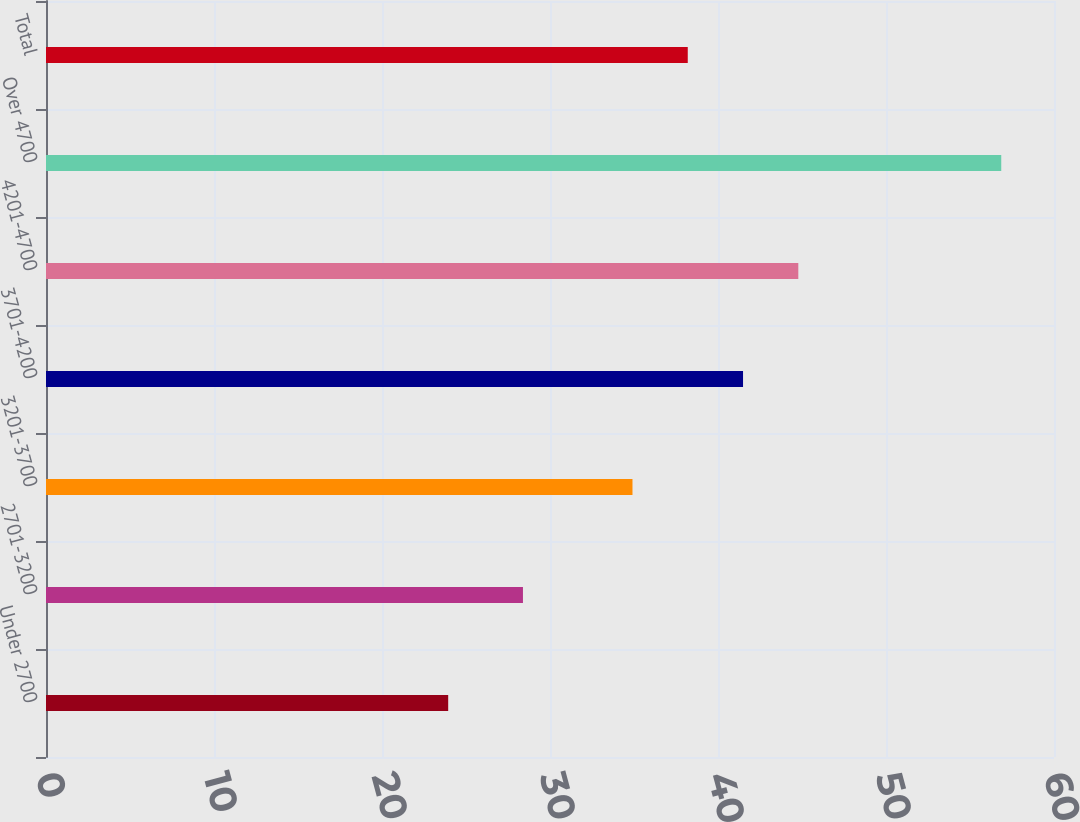Convert chart to OTSL. <chart><loc_0><loc_0><loc_500><loc_500><bar_chart><fcel>Under 2700<fcel>2701-3200<fcel>3201-3700<fcel>3701-4200<fcel>4201-4700<fcel>Over 4700<fcel>Total<nl><fcel>23.94<fcel>28.39<fcel>34.91<fcel>41.49<fcel>44.78<fcel>56.86<fcel>38.2<nl></chart> 